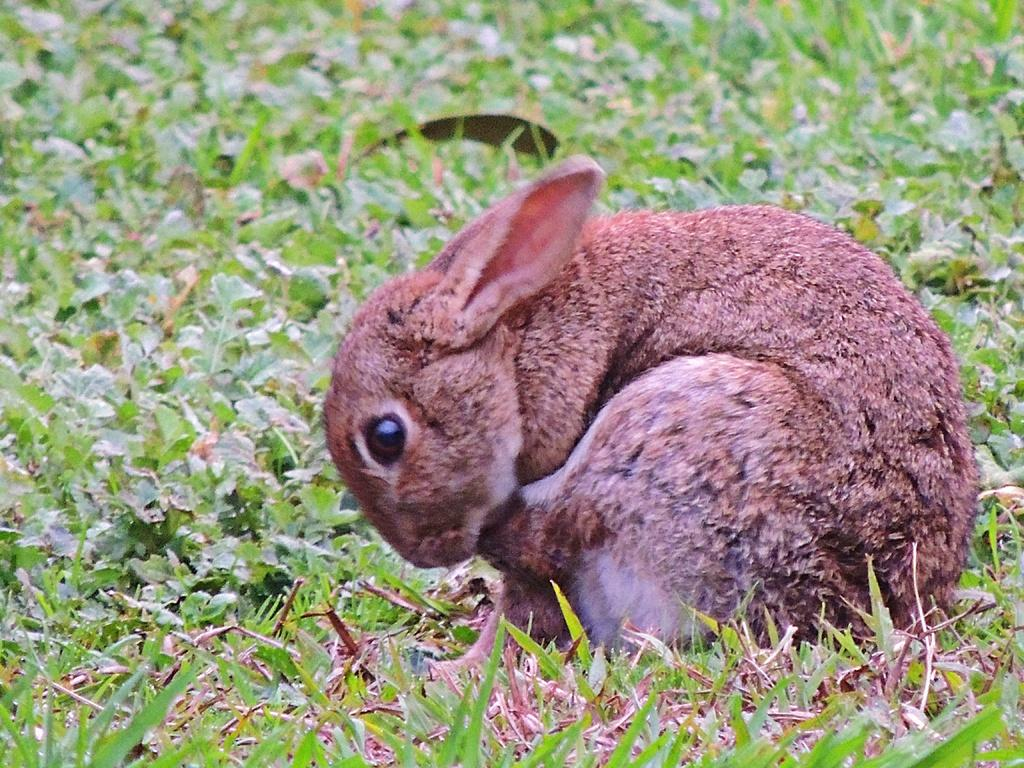What type of animal is present in the image? There is a rabbit in the image. What else can be seen in the image besides the rabbit? There are plants and grass on the ground in the image. What type of pies are being served at the chess game in the image? There is no chess game or pies present in the image; it features a rabbit, plants, and grass. 